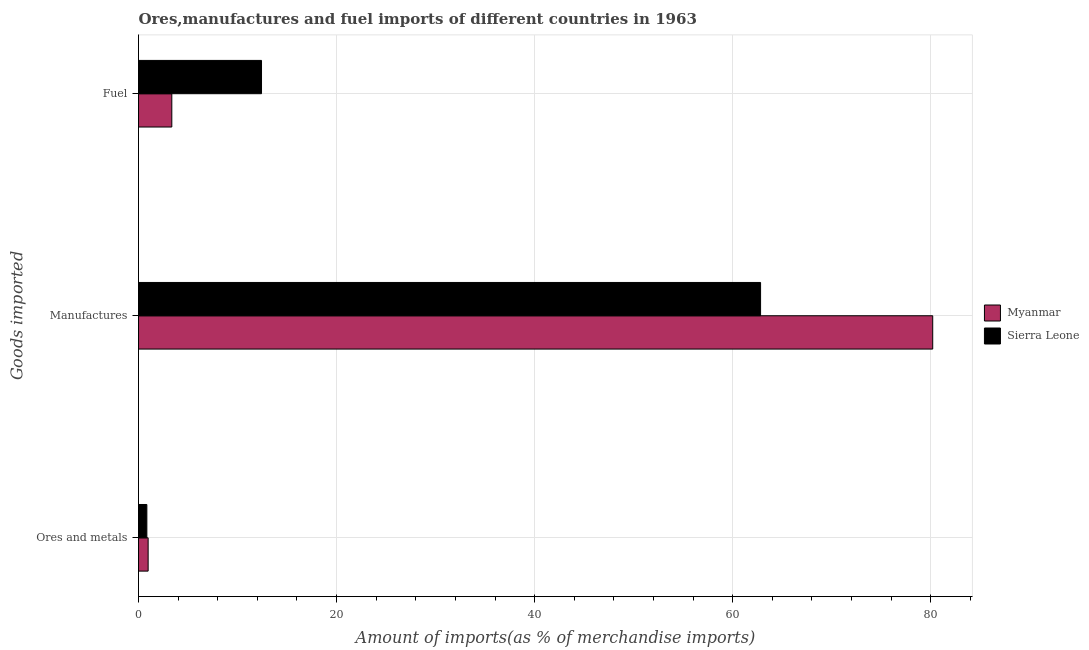How many groups of bars are there?
Offer a very short reply. 3. Are the number of bars per tick equal to the number of legend labels?
Your answer should be very brief. Yes. What is the label of the 3rd group of bars from the top?
Your response must be concise. Ores and metals. What is the percentage of manufactures imports in Myanmar?
Offer a very short reply. 80.2. Across all countries, what is the maximum percentage of ores and metals imports?
Ensure brevity in your answer.  0.97. Across all countries, what is the minimum percentage of ores and metals imports?
Make the answer very short. 0.84. In which country was the percentage of manufactures imports maximum?
Offer a terse response. Myanmar. In which country was the percentage of manufactures imports minimum?
Make the answer very short. Sierra Leone. What is the total percentage of ores and metals imports in the graph?
Make the answer very short. 1.82. What is the difference between the percentage of fuel imports in Sierra Leone and that in Myanmar?
Provide a succinct answer. 9.06. What is the difference between the percentage of fuel imports in Myanmar and the percentage of manufactures imports in Sierra Leone?
Your response must be concise. -59.45. What is the average percentage of ores and metals imports per country?
Offer a very short reply. 0.91. What is the difference between the percentage of fuel imports and percentage of ores and metals imports in Sierra Leone?
Make the answer very short. 11.58. What is the ratio of the percentage of ores and metals imports in Myanmar to that in Sierra Leone?
Offer a very short reply. 1.16. What is the difference between the highest and the second highest percentage of ores and metals imports?
Your answer should be compact. 0.13. What is the difference between the highest and the lowest percentage of fuel imports?
Offer a very short reply. 9.06. Is the sum of the percentage of manufactures imports in Myanmar and Sierra Leone greater than the maximum percentage of fuel imports across all countries?
Offer a very short reply. Yes. What does the 1st bar from the top in Fuel represents?
Provide a succinct answer. Sierra Leone. What does the 2nd bar from the bottom in Manufactures represents?
Offer a very short reply. Sierra Leone. Is it the case that in every country, the sum of the percentage of ores and metals imports and percentage of manufactures imports is greater than the percentage of fuel imports?
Give a very brief answer. Yes. Are all the bars in the graph horizontal?
Your answer should be compact. Yes. Does the graph contain any zero values?
Your answer should be very brief. No. Does the graph contain grids?
Make the answer very short. Yes. How are the legend labels stacked?
Your response must be concise. Vertical. What is the title of the graph?
Give a very brief answer. Ores,manufactures and fuel imports of different countries in 1963. Does "Mauritius" appear as one of the legend labels in the graph?
Ensure brevity in your answer.  No. What is the label or title of the X-axis?
Your answer should be very brief. Amount of imports(as % of merchandise imports). What is the label or title of the Y-axis?
Make the answer very short. Goods imported. What is the Amount of imports(as % of merchandise imports) in Myanmar in Ores and metals?
Offer a terse response. 0.97. What is the Amount of imports(as % of merchandise imports) in Sierra Leone in Ores and metals?
Provide a succinct answer. 0.84. What is the Amount of imports(as % of merchandise imports) in Myanmar in Manufactures?
Provide a short and direct response. 80.2. What is the Amount of imports(as % of merchandise imports) in Sierra Leone in Manufactures?
Provide a short and direct response. 62.82. What is the Amount of imports(as % of merchandise imports) in Myanmar in Fuel?
Your answer should be compact. 3.36. What is the Amount of imports(as % of merchandise imports) of Sierra Leone in Fuel?
Your answer should be very brief. 12.42. Across all Goods imported, what is the maximum Amount of imports(as % of merchandise imports) of Myanmar?
Offer a terse response. 80.2. Across all Goods imported, what is the maximum Amount of imports(as % of merchandise imports) in Sierra Leone?
Make the answer very short. 62.82. Across all Goods imported, what is the minimum Amount of imports(as % of merchandise imports) of Myanmar?
Your answer should be compact. 0.97. Across all Goods imported, what is the minimum Amount of imports(as % of merchandise imports) of Sierra Leone?
Provide a succinct answer. 0.84. What is the total Amount of imports(as % of merchandise imports) in Myanmar in the graph?
Make the answer very short. 84.54. What is the total Amount of imports(as % of merchandise imports) of Sierra Leone in the graph?
Your answer should be very brief. 76.08. What is the difference between the Amount of imports(as % of merchandise imports) in Myanmar in Ores and metals and that in Manufactures?
Your response must be concise. -79.23. What is the difference between the Amount of imports(as % of merchandise imports) of Sierra Leone in Ores and metals and that in Manufactures?
Your answer should be very brief. -61.97. What is the difference between the Amount of imports(as % of merchandise imports) of Myanmar in Ores and metals and that in Fuel?
Your response must be concise. -2.39. What is the difference between the Amount of imports(as % of merchandise imports) of Sierra Leone in Ores and metals and that in Fuel?
Your answer should be very brief. -11.58. What is the difference between the Amount of imports(as % of merchandise imports) of Myanmar in Manufactures and that in Fuel?
Make the answer very short. 76.84. What is the difference between the Amount of imports(as % of merchandise imports) of Sierra Leone in Manufactures and that in Fuel?
Provide a succinct answer. 50.4. What is the difference between the Amount of imports(as % of merchandise imports) of Myanmar in Ores and metals and the Amount of imports(as % of merchandise imports) of Sierra Leone in Manufactures?
Your answer should be compact. -61.84. What is the difference between the Amount of imports(as % of merchandise imports) of Myanmar in Ores and metals and the Amount of imports(as % of merchandise imports) of Sierra Leone in Fuel?
Ensure brevity in your answer.  -11.45. What is the difference between the Amount of imports(as % of merchandise imports) of Myanmar in Manufactures and the Amount of imports(as % of merchandise imports) of Sierra Leone in Fuel?
Make the answer very short. 67.78. What is the average Amount of imports(as % of merchandise imports) of Myanmar per Goods imported?
Give a very brief answer. 28.18. What is the average Amount of imports(as % of merchandise imports) of Sierra Leone per Goods imported?
Give a very brief answer. 25.36. What is the difference between the Amount of imports(as % of merchandise imports) in Myanmar and Amount of imports(as % of merchandise imports) in Sierra Leone in Ores and metals?
Provide a succinct answer. 0.13. What is the difference between the Amount of imports(as % of merchandise imports) in Myanmar and Amount of imports(as % of merchandise imports) in Sierra Leone in Manufactures?
Your response must be concise. 17.38. What is the difference between the Amount of imports(as % of merchandise imports) in Myanmar and Amount of imports(as % of merchandise imports) in Sierra Leone in Fuel?
Make the answer very short. -9.06. What is the ratio of the Amount of imports(as % of merchandise imports) of Myanmar in Ores and metals to that in Manufactures?
Your response must be concise. 0.01. What is the ratio of the Amount of imports(as % of merchandise imports) of Sierra Leone in Ores and metals to that in Manufactures?
Make the answer very short. 0.01. What is the ratio of the Amount of imports(as % of merchandise imports) in Myanmar in Ores and metals to that in Fuel?
Ensure brevity in your answer.  0.29. What is the ratio of the Amount of imports(as % of merchandise imports) of Sierra Leone in Ores and metals to that in Fuel?
Provide a succinct answer. 0.07. What is the ratio of the Amount of imports(as % of merchandise imports) in Myanmar in Manufactures to that in Fuel?
Offer a terse response. 23.85. What is the ratio of the Amount of imports(as % of merchandise imports) in Sierra Leone in Manufactures to that in Fuel?
Offer a terse response. 5.06. What is the difference between the highest and the second highest Amount of imports(as % of merchandise imports) in Myanmar?
Offer a terse response. 76.84. What is the difference between the highest and the second highest Amount of imports(as % of merchandise imports) in Sierra Leone?
Your answer should be compact. 50.4. What is the difference between the highest and the lowest Amount of imports(as % of merchandise imports) in Myanmar?
Offer a terse response. 79.23. What is the difference between the highest and the lowest Amount of imports(as % of merchandise imports) of Sierra Leone?
Ensure brevity in your answer.  61.97. 